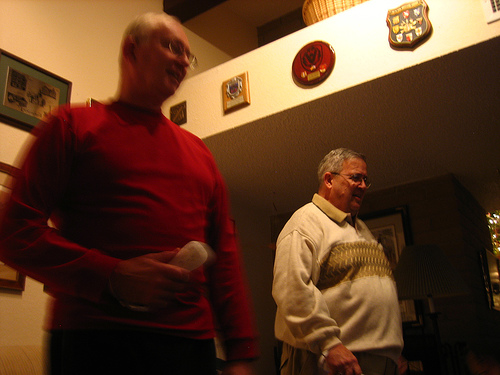Do you see a dog next to the person that is holding the remote control? There is no dog next to the man holding the remote control in this image. 